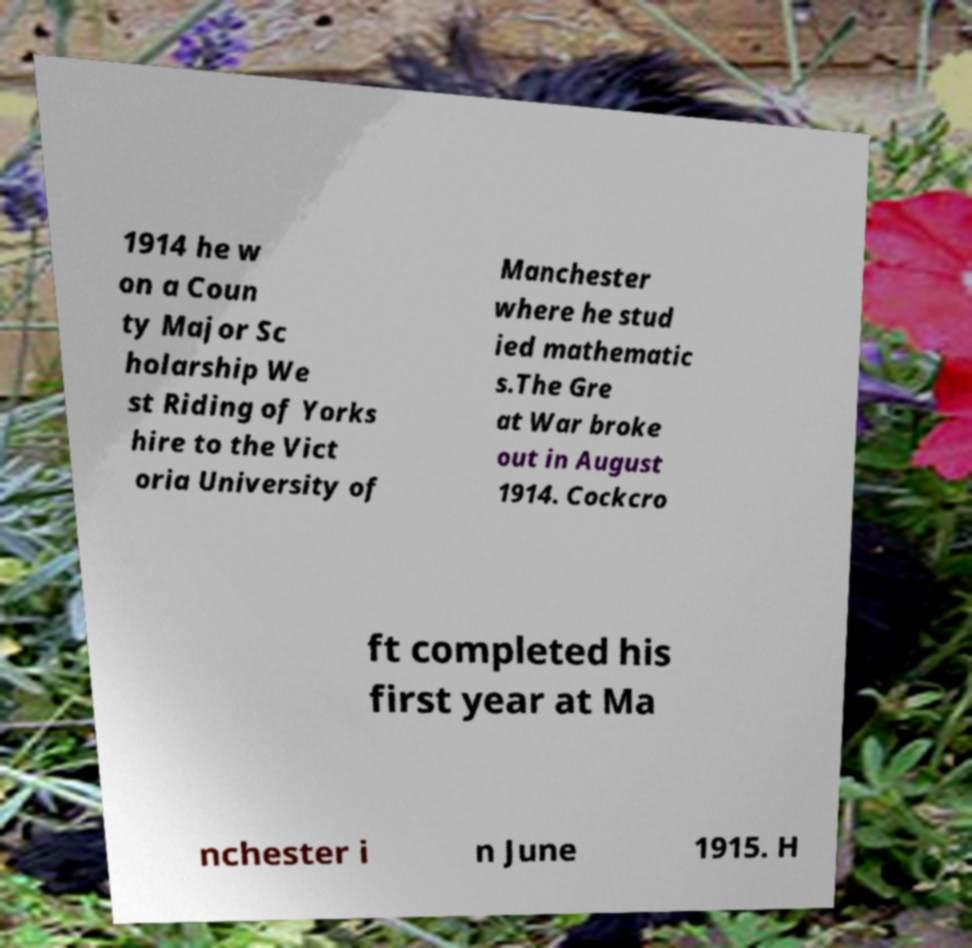Could you assist in decoding the text presented in this image and type it out clearly? 1914 he w on a Coun ty Major Sc holarship We st Riding of Yorks hire to the Vict oria University of Manchester where he stud ied mathematic s.The Gre at War broke out in August 1914. Cockcro ft completed his first year at Ma nchester i n June 1915. H 